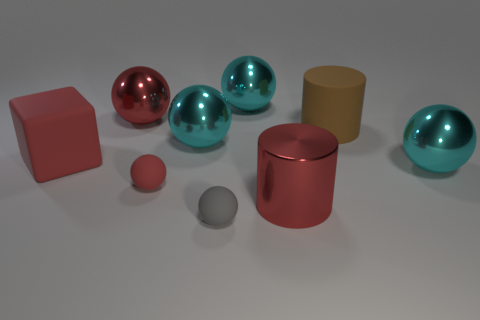How would you describe the arrangement of objects? The objects are arranged in an unordered fashion across a flat surface, providing a comparative view of different geometrical shapes and sizes. What colors do you see in the image? There are multiple colors visible: a couple of the spheres have a shiny, reflective surface with hues of pink and teal, while the cylinders are matte red and yellow. There's also a neutral gray sphere and a pink cube. 